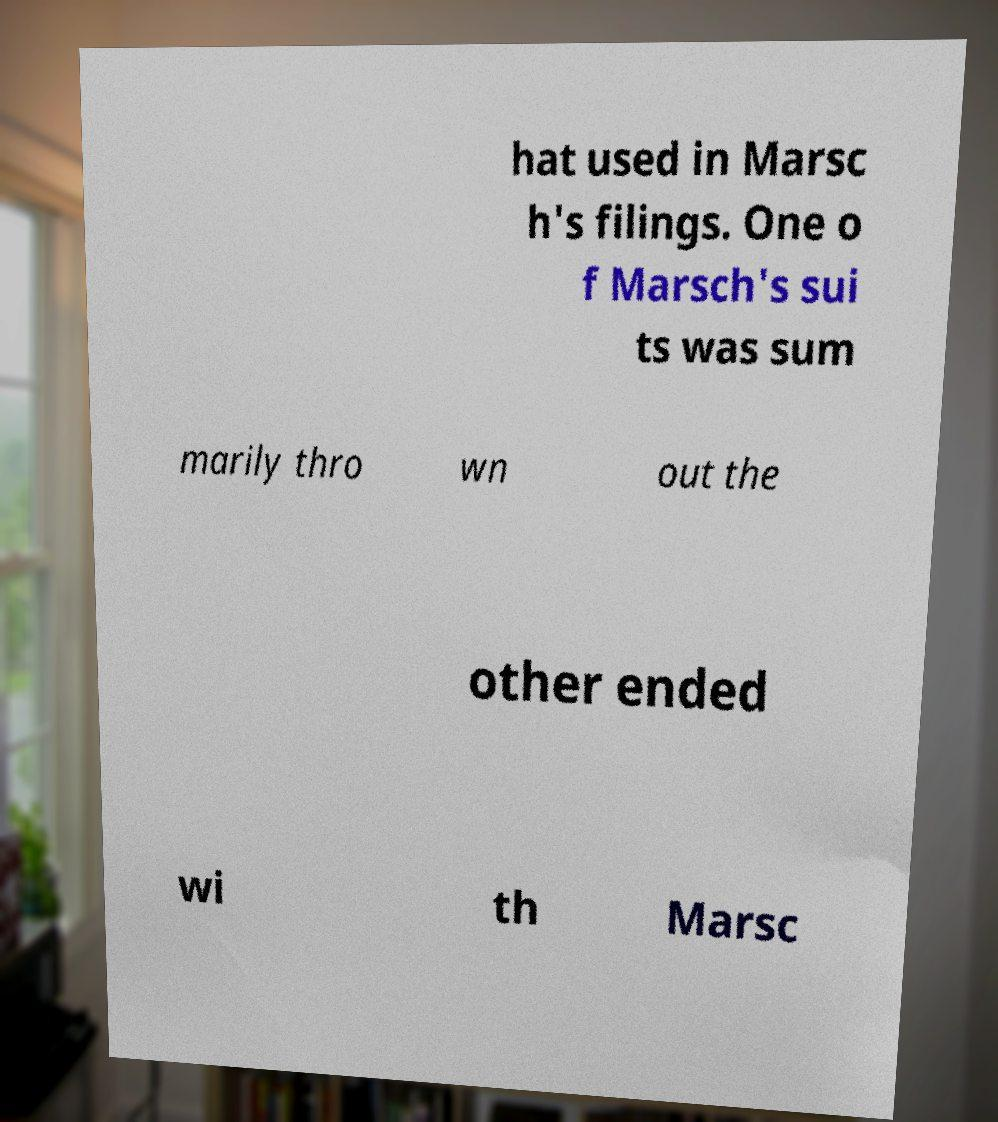Can you accurately transcribe the text from the provided image for me? hat used in Marsc h's filings. One o f Marsch's sui ts was sum marily thro wn out the other ended wi th Marsc 